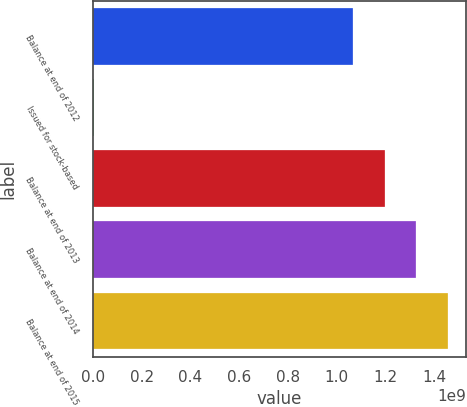Convert chart. <chart><loc_0><loc_0><loc_500><loc_500><bar_chart><fcel>Balance at end of 2012<fcel>Issued for stock-based<fcel>Balance at end of 2013<fcel>Balance at end of 2014<fcel>Balance at end of 2015<nl><fcel>1.06721e+09<fcel>3.7989e+06<fcel>1.19785e+09<fcel>1.32848e+09<fcel>1.45912e+09<nl></chart> 